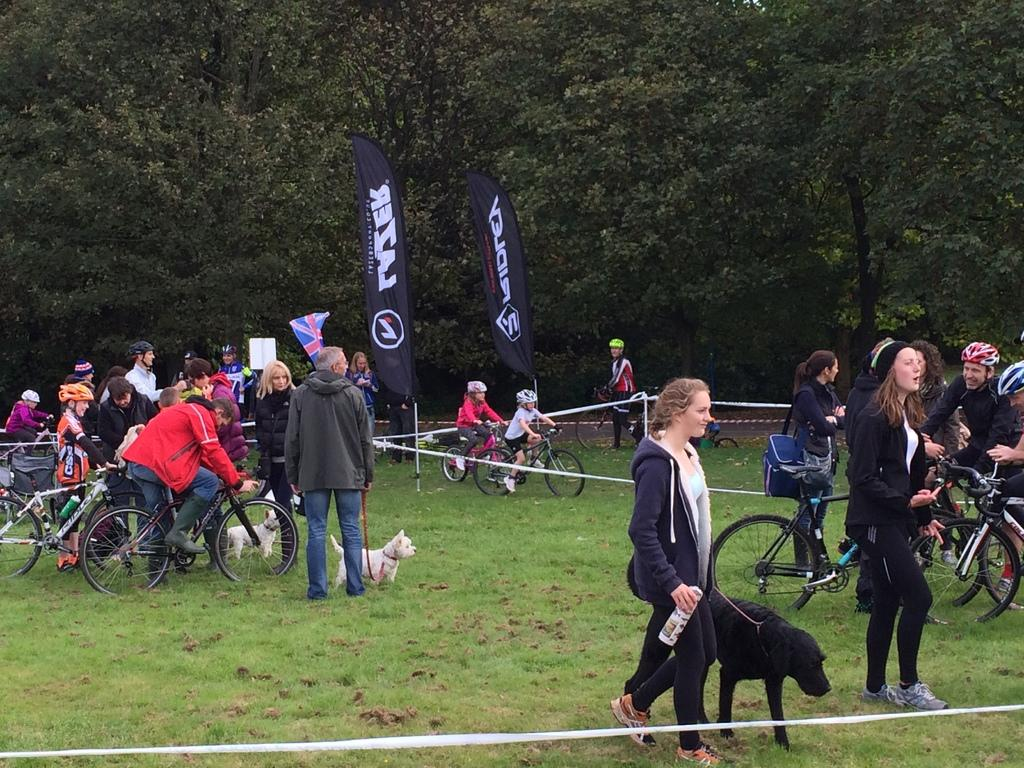Who or what can be seen in the image? There are people in the image. What are the people doing with the dogs? The people are holding dogs in the image. What type of terrain is visible in the image? There is grass visible in the image. What can be seen in the background of the image? There are trees in the background of the image. What is the title of the book the people are reading in the image? There is no book or reading activity depicted in the image; it features people holding dogs and engaging in other activities. 